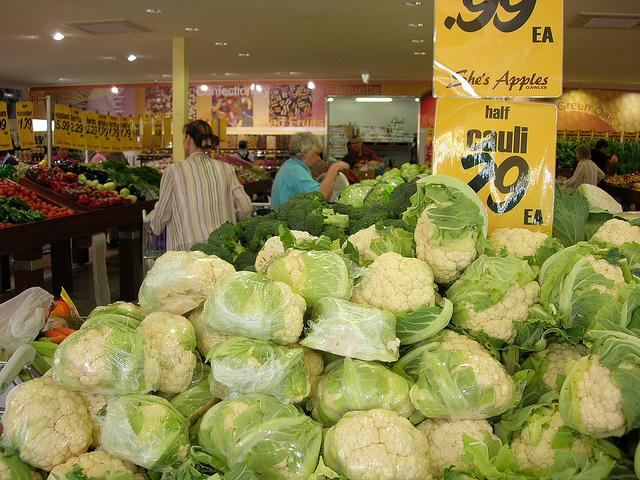Are the women shopping?
Answer briefly. Yes. Is there a florist in the market?
Keep it brief. No. What food is in front?
Short answer required. Cauliflower. Are the people adults?
Short answer required. Yes. What vegetable is on the right of this scene?
Give a very brief answer. Cauliflower. Are all of the overhead lights on?
Answer briefly. Yes. 